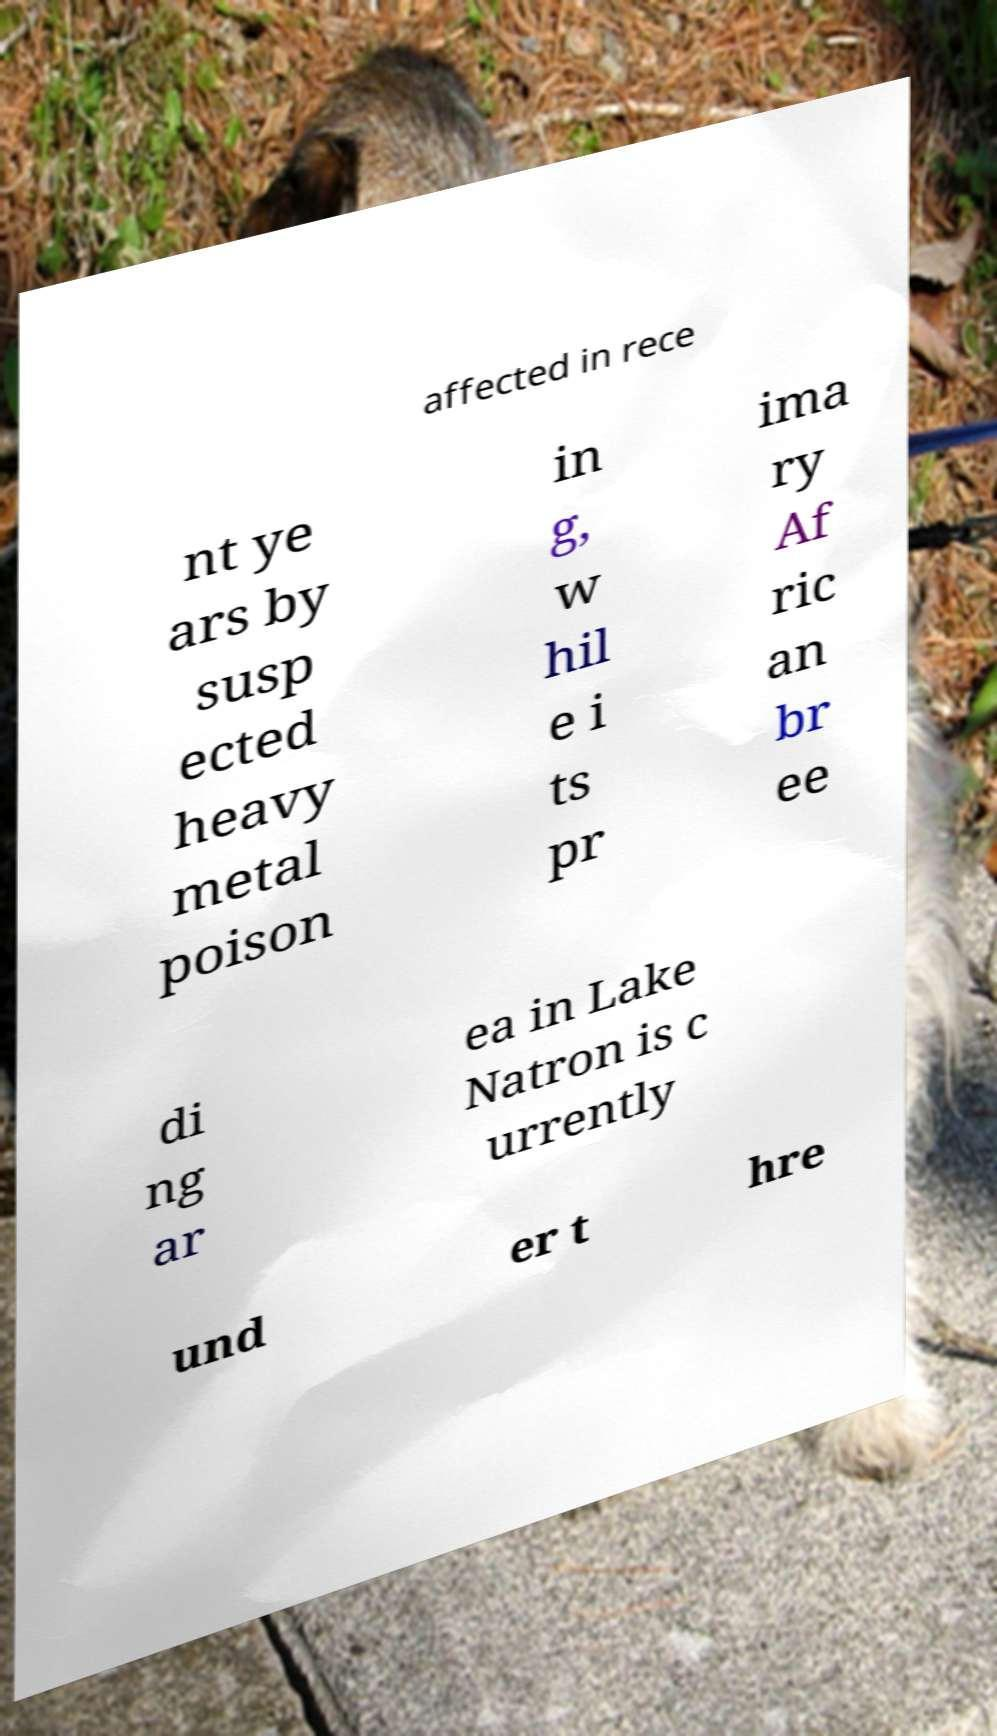Please read and relay the text visible in this image. What does it say? affected in rece nt ye ars by susp ected heavy metal poison in g, w hil e i ts pr ima ry Af ric an br ee di ng ar ea in Lake Natron is c urrently und er t hre 